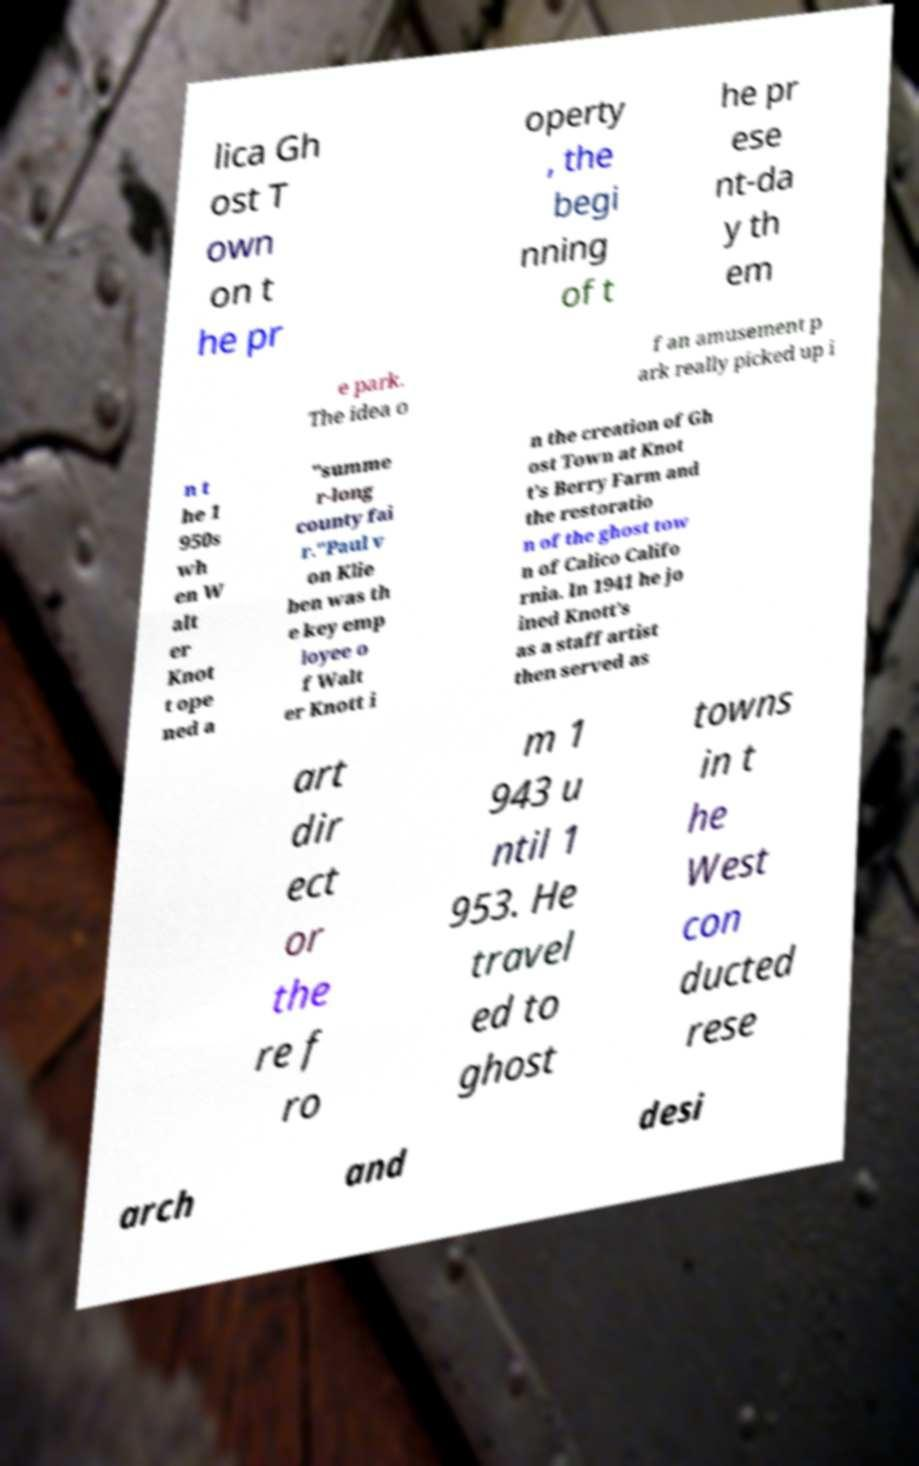Please read and relay the text visible in this image. What does it say? lica Gh ost T own on t he pr operty , the begi nning of t he pr ese nt-da y th em e park. The idea o f an amusement p ark really picked up i n t he 1 950s wh en W alt er Knot t ope ned a "summe r-long county fai r."Paul v on Klie ben was th e key emp loyee o f Walt er Knott i n the creation of Gh ost Town at Knot t’s Berry Farm and the restoratio n of the ghost tow n of Calico Califo rnia. In 1941 he jo ined Knott’s as a staff artist then served as art dir ect or the re f ro m 1 943 u ntil 1 953. He travel ed to ghost towns in t he West con ducted rese arch and desi 